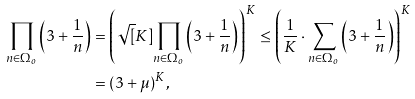Convert formula to latex. <formula><loc_0><loc_0><loc_500><loc_500>\prod _ { n \in \Omega _ { o } } \left ( 3 + \frac { 1 } { n } \right ) & = \left ( \sqrt { [ } K ] { \prod _ { n \in \Omega _ { o } } \left ( 3 + \frac { 1 } { n } \right ) } \right ) ^ { K } \leq \left ( \frac { 1 } { K } \cdot \sum _ { n \in \Omega _ { o } } \left ( 3 + \frac { 1 } { n } \right ) \right ) ^ { K } \\ & = ( 3 + \mu ) ^ { K } ,</formula> 